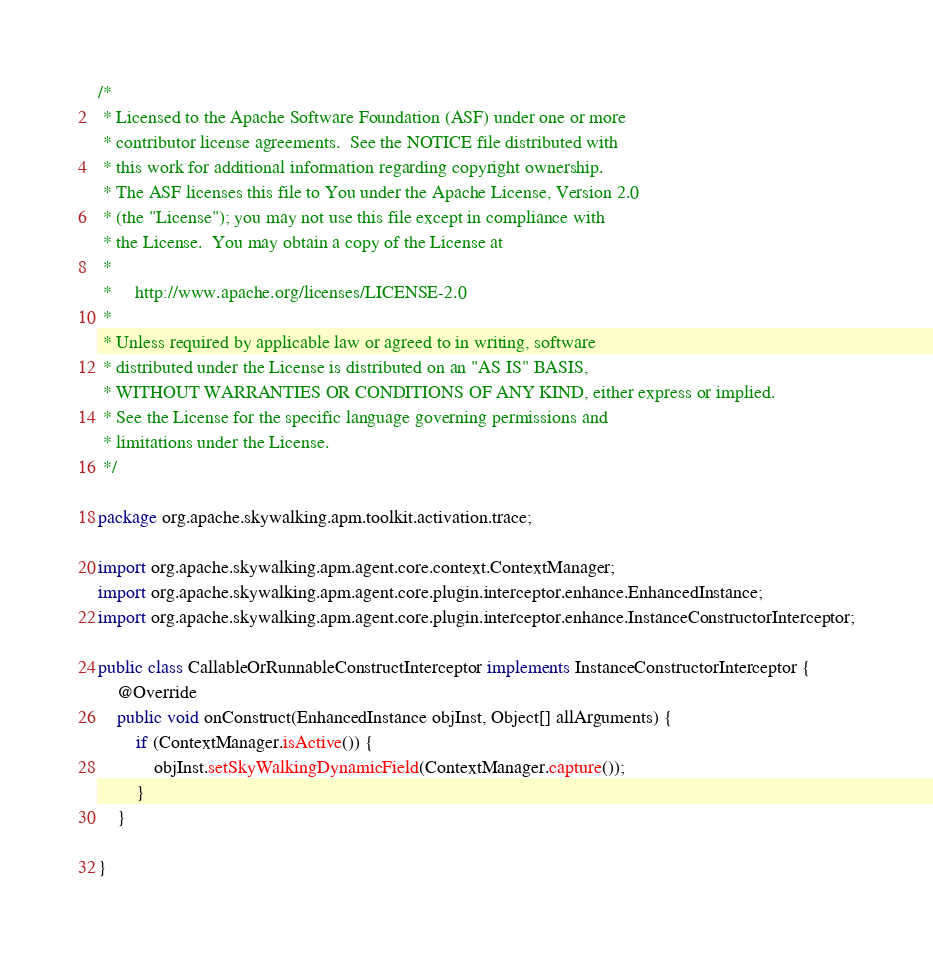<code> <loc_0><loc_0><loc_500><loc_500><_Java_>/*
 * Licensed to the Apache Software Foundation (ASF) under one or more
 * contributor license agreements.  See the NOTICE file distributed with
 * this work for additional information regarding copyright ownership.
 * The ASF licenses this file to You under the Apache License, Version 2.0
 * (the "License"); you may not use this file except in compliance with
 * the License.  You may obtain a copy of the License at
 *
 *     http://www.apache.org/licenses/LICENSE-2.0
 *
 * Unless required by applicable law or agreed to in writing, software
 * distributed under the License is distributed on an "AS IS" BASIS,
 * WITHOUT WARRANTIES OR CONDITIONS OF ANY KIND, either express or implied.
 * See the License for the specific language governing permissions and
 * limitations under the License.
 */

package org.apache.skywalking.apm.toolkit.activation.trace;

import org.apache.skywalking.apm.agent.core.context.ContextManager;
import org.apache.skywalking.apm.agent.core.plugin.interceptor.enhance.EnhancedInstance;
import org.apache.skywalking.apm.agent.core.plugin.interceptor.enhance.InstanceConstructorInterceptor;

public class CallableOrRunnableConstructInterceptor implements InstanceConstructorInterceptor {
    @Override
    public void onConstruct(EnhancedInstance objInst, Object[] allArguments) {
        if (ContextManager.isActive()) {
            objInst.setSkyWalkingDynamicField(ContextManager.capture());
        }
    }

}
</code> 